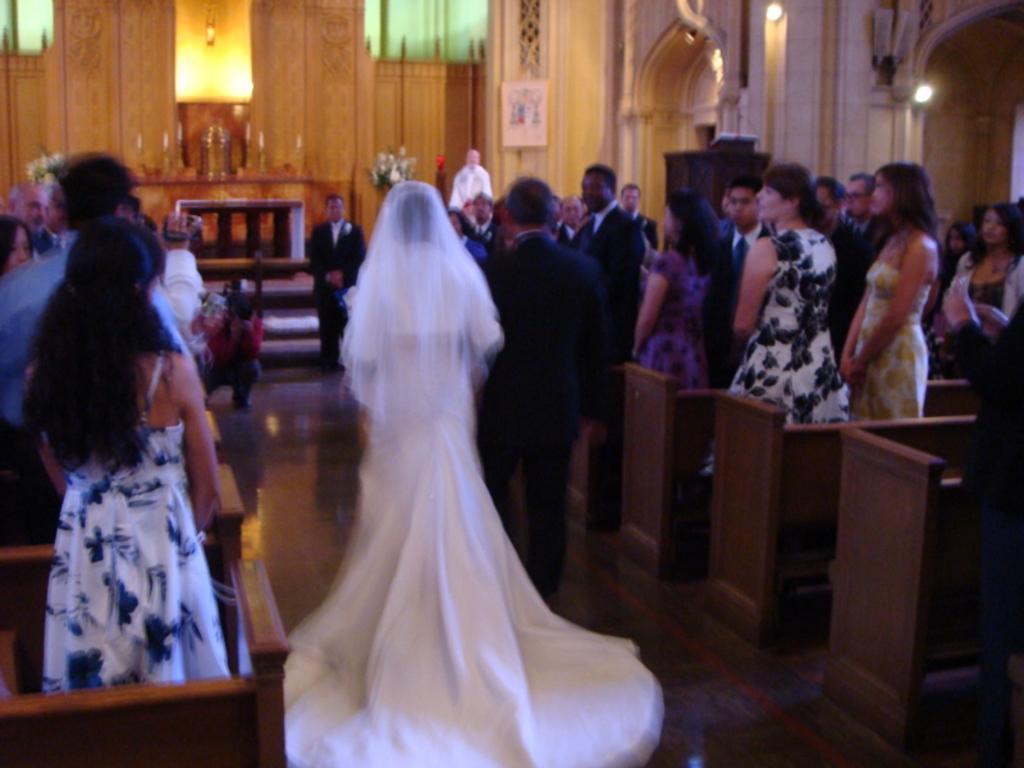How would you summarize this image in a sentence or two? In the center of the image we can see a lady and a man standing. In the background there are people and we can see benches. There is an alter. On the right there are lights and we can see a door. 